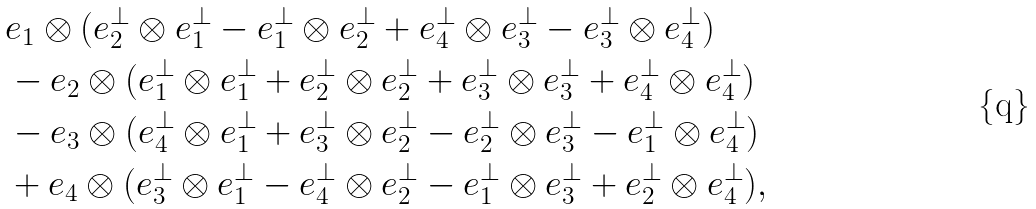Convert formula to latex. <formula><loc_0><loc_0><loc_500><loc_500>& e _ { 1 } \otimes ( e _ { 2 } ^ { \perp } \otimes e _ { 1 } ^ { \perp } - e _ { 1 } ^ { \perp } \otimes e _ { 2 } ^ { \perp } + e _ { 4 } ^ { \perp } \otimes e _ { 3 } ^ { \perp } - e _ { 3 } ^ { \perp } \otimes e _ { 4 } ^ { \perp } ) \\ & - e _ { 2 } \otimes ( e _ { 1 } ^ { \perp } \otimes e _ { 1 } ^ { \perp } + e _ { 2 } ^ { \perp } \otimes e _ { 2 } ^ { \perp } + e _ { 3 } ^ { \perp } \otimes e _ { 3 } ^ { \perp } + e _ { 4 } ^ { \perp } \otimes e _ { 4 } ^ { \perp } ) \\ & - e _ { 3 } \otimes ( e _ { 4 } ^ { \perp } \otimes e _ { 1 } ^ { \perp } + e _ { 3 } ^ { \perp } \otimes e _ { 2 } ^ { \perp } - e _ { 2 } ^ { \perp } \otimes e _ { 3 } ^ { \perp } - e _ { 1 } ^ { \perp } \otimes e _ { 4 } ^ { \perp } ) \\ & + e _ { 4 } \otimes ( e _ { 3 } ^ { \perp } \otimes e _ { 1 } ^ { \perp } - e _ { 4 } ^ { \perp } \otimes e _ { 2 } ^ { \perp } - e _ { 1 } ^ { \perp } \otimes e _ { 3 } ^ { \perp } + e _ { 2 } ^ { \perp } \otimes e _ { 4 } ^ { \perp } ) ,</formula> 